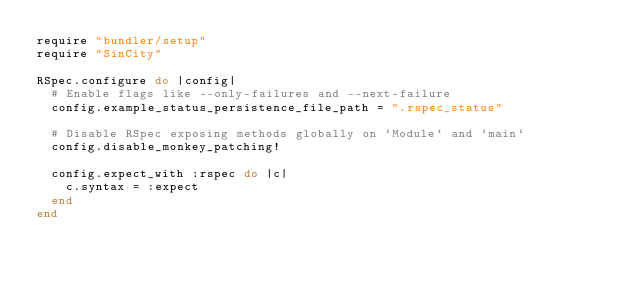Convert code to text. <code><loc_0><loc_0><loc_500><loc_500><_Ruby_>require "bundler/setup"
require "SinCity"

RSpec.configure do |config|
  # Enable flags like --only-failures and --next-failure
  config.example_status_persistence_file_path = ".rspec_status"

  # Disable RSpec exposing methods globally on `Module` and `main`
  config.disable_monkey_patching!

  config.expect_with :rspec do |c|
    c.syntax = :expect
  end
end
</code> 